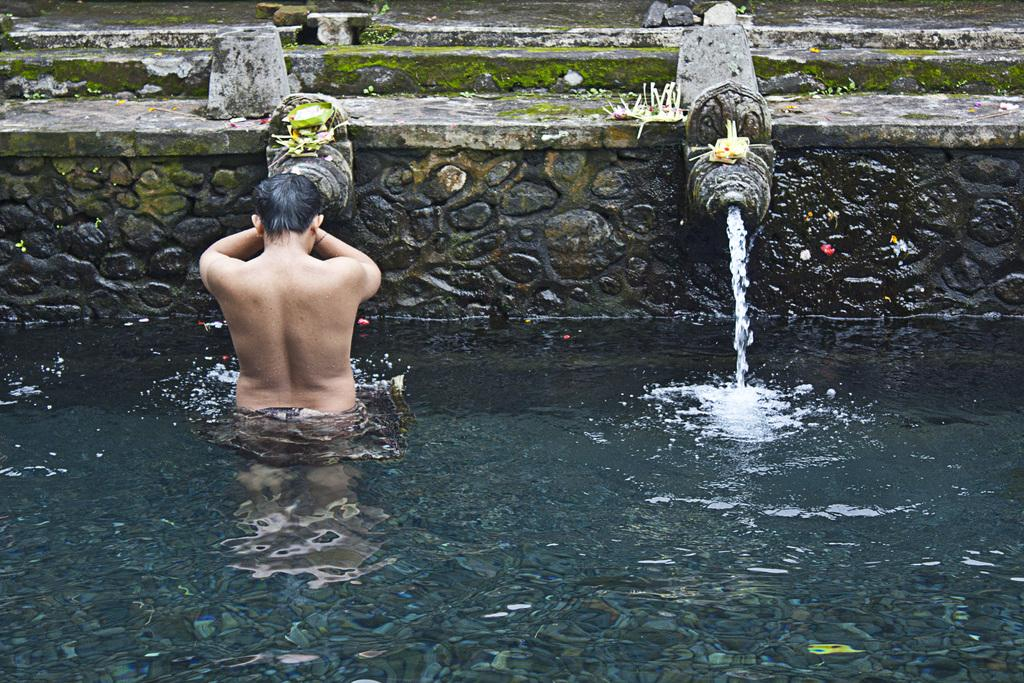What is at the bottom of the image? There is water at the bottom of the image. What is the person in the image doing? A person is standing in the water. What can be seen behind the person? There is fencing behind the person. What type of tools does the carpenter have in the image? There is no carpenter present in the image. Is the person in the image taking a bath? The image does not provide enough information to determine if the person is taking a bath or not. 